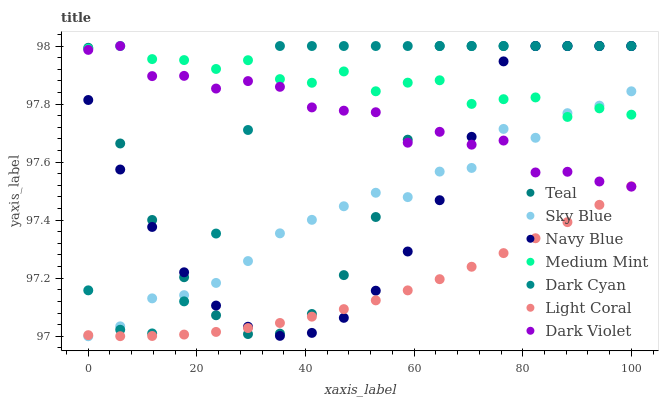Does Light Coral have the minimum area under the curve?
Answer yes or no. Yes. Does Medium Mint have the maximum area under the curve?
Answer yes or no. Yes. Does Navy Blue have the minimum area under the curve?
Answer yes or no. No. Does Navy Blue have the maximum area under the curve?
Answer yes or no. No. Is Light Coral the smoothest?
Answer yes or no. Yes. Is Dark Violet the roughest?
Answer yes or no. Yes. Is Navy Blue the smoothest?
Answer yes or no. No. Is Navy Blue the roughest?
Answer yes or no. No. Does Sky Blue have the lowest value?
Answer yes or no. Yes. Does Navy Blue have the lowest value?
Answer yes or no. No. Does Dark Cyan have the highest value?
Answer yes or no. Yes. Does Light Coral have the highest value?
Answer yes or no. No. Is Light Coral less than Medium Mint?
Answer yes or no. Yes. Is Medium Mint greater than Light Coral?
Answer yes or no. Yes. Does Sky Blue intersect Light Coral?
Answer yes or no. Yes. Is Sky Blue less than Light Coral?
Answer yes or no. No. Is Sky Blue greater than Light Coral?
Answer yes or no. No. Does Light Coral intersect Medium Mint?
Answer yes or no. No. 